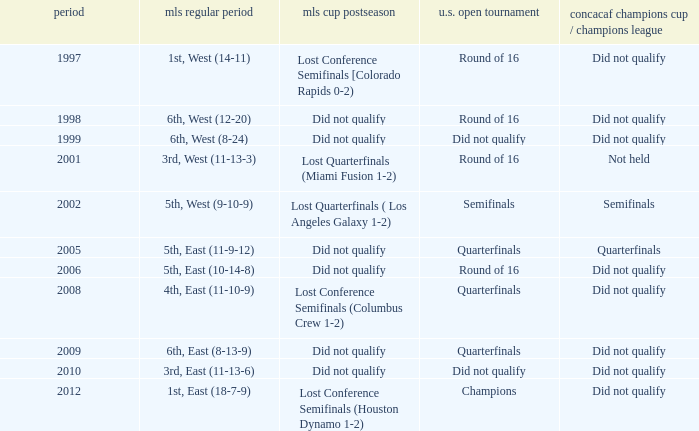What were the placements of the team in regular season when they reached quarterfinals in the U.S. Open Cup but did not qualify for the Concaf Champions Cup? 4th, East (11-10-9), 6th, East (8-13-9). 